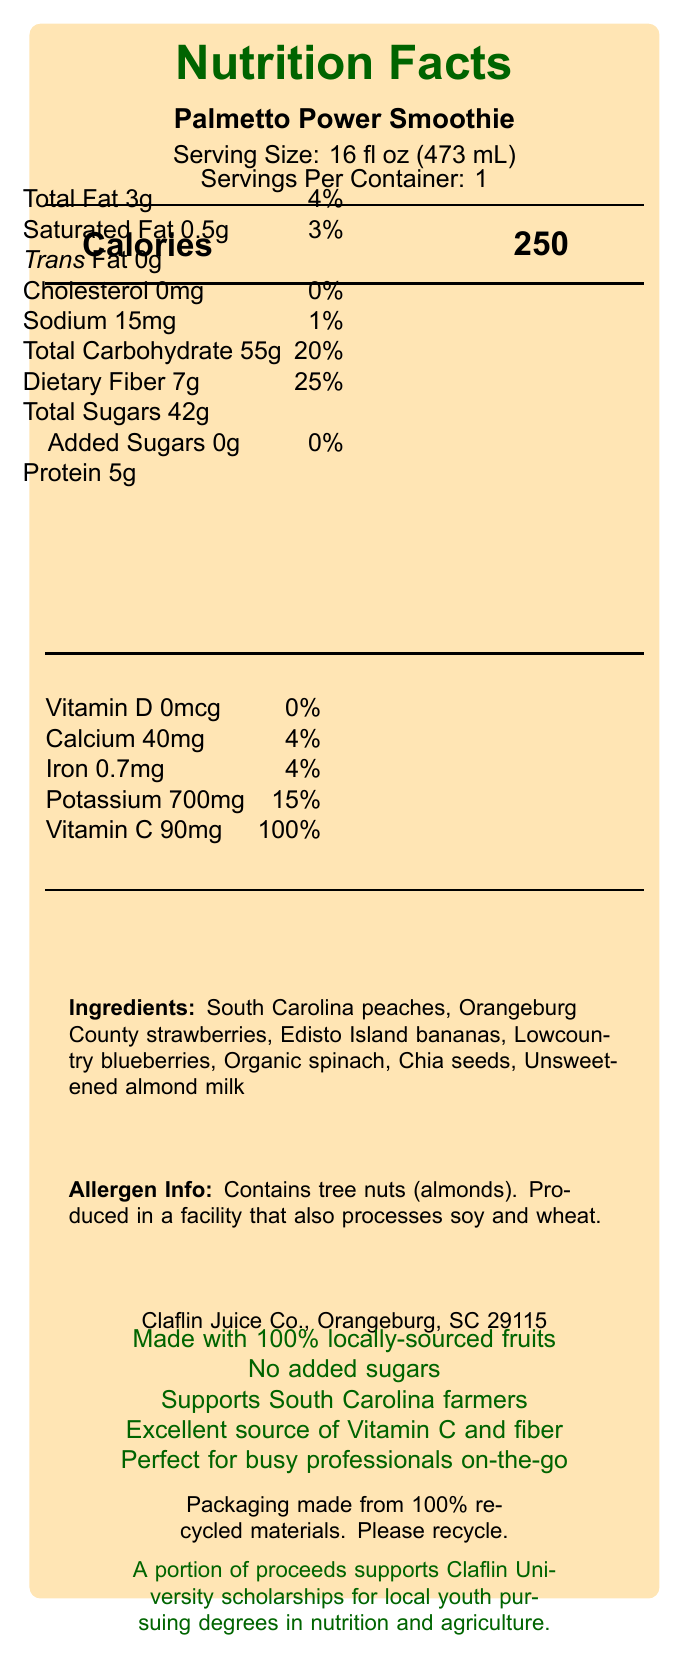what is the serving size of the Palmetto Power Smoothie? The document lists the serving size directly under the product name "Palmetto Power Smoothie" as "16 fl oz (473 mL)."
Answer: 16 fl oz (473 mL) how many calories does one serving of the Palmetto Power Smoothie contain? The document specifies the calories value next to the label "Calories".
Answer: 250 how much dietary fiber is in the Palmetto Power Smoothie? The document shows "Dietary Fiber 7g" under the nutrition facts.
Answer: 7g what ingredients are used in the Palmetto Power Smoothie? The document lists the ingredients under the "Ingredients" section.
Answer: South Carolina peaches, Orangeburg County strawberries, Edisto Island bananas, Lowcountry blueberries, Organic spinach, Chia seeds, Unsweetened almond milk does the Palmetto Power Smoothie contain any added sugars? Under the nutrition facts, the document states "Added Sugars 0g."
Answer: No does the Palmetto Power Smoothie contain any potentially allergenic ingredients? The allergen info mentions it contains tree nuts (almonds).
Answer: Yes who produces the Palmetto Power Smoothie? A. Orangeburg Juice Co., Orangeburg B. Claflin Juice Co., Orangeburg C. South Carolina Juice Co., Columbia D. Edisto Island Juice Co., Edisto Island The document states the producer as "Claflin Juice Co., Orangeburg, SC 29115."
Answer: B. Claflin Juice Co., Orangeburg what percentage of the daily value of Vitamin C does the Palmetto Power Smoothie provide? A. 50% B. 75% C. 100% D. 150% The document lists "Vitamin C 90mg" providing "100%".
Answer: C. 100% does the Palmetto Power Smoothie have any cholesterol? The document indicates "Cholesterol 0mg".
Answer: No does the product contain a sustainability statement? The document states "Packaging made from 100% recycled materials. Please recycle."
Answer: Yes can you summarize the main idea of the Palmetto Power Smoothie document? The document details the nutritional content and ingredients of the smoothie, along with promoting its local sourcing, health benefits, and community support.
Answer: The document provides the nutrition facts, ingredients, allergen information, and marketing claims for the Palmetto Power Smoothie. It highlights that the smoothie is made with locally sourced fruits, contains no added sugars, and supports local farmers and scholarships for youth. what is the total amount of potassium in the Palmetto Power Smoothie? The nutrition facts show "Potassium 700mg."
Answer: 700mg does this smoothie support any educational initiatives? The document mentions that a portion of proceeds supports scholarships for local youth.
Answer: Yes where are the bananas in the Palmetto Power Smoothie sourced from? The document lists "Edisto Island bananas" under ingredients.
Answer: Edisto Island is there any information about sugar content besides total sugars? The document specifies both "Total Sugars 42g" and "Added Sugars 0g."
Answer: Yes, it states that there are 0g of added sugars. how much protein does one serving of the Palmetto Power Smoothie contain? The document lists "Protein 5g."
Answer: 5g how many servings are there per container? The document specifies "Servings Per Container: 1."
Answer: 1 what marketing claims are made about the Palmetto Power Smoothie? The document lists the marketing claims under the section labeled for marketing claims.
Answer: Made with 100% locally-sourced fruits, No added sugars, Supports South Carolina farmers, Excellent source of Vitamin C and fiber, Perfect for busy professionals on-the-go what is the total fat content in one serving, and what percentage of the daily value does it provide? The nutrition facts state "Total Fat 3g" and "4%."
Answer: 3g, 4% what information is available about the vitamin D content in the smoothie? The nutrition facts display "Vitamin D 0mcg, 0%."
Answer: The smoothie contains 0mcg of Vitamin D, providing 0% of the daily value. what is the company's address? The document shows the company's address as "Claflin Juice Co., Orangeburg, SC 29115."
Answer: Orangeburg, SC 29115 does the Palmetto Power Smoothie have more fiber or sugars? The document states "Dietary Fiber 7g" and "Total Sugars 42g," so the smoothie has more sugars.
Answer: Sugars which fruit is not mentioned as an ingredient? A. Strawberries B. Blueberries C. Cherries D. Peaches The list of ingredients does not mention cherries, while it mentions strawberries, blueberries, and peaches.
Answer: C. Cherries how much iron does the Palmetto Power Smoothie provide? The document states the iron content as "Iron 0.7mg, 4%."
Answer: 0.7mg, 4% is there any information about the ethical or environmental impact of the product's packaging? The document mentions the packaging and recycling statement under sustainability.
Answer: Yes, the packaging is made from 100% recycled materials, and consumers are encouraged to recycle. what flavors are emphasized in the ingredients list? The ingredients list emphasizes flavors from "South Carolina peaches, Orangeburg County strawberries, Edisto Island bananas, Lowcountry blueberries."
Answer: Peach, strawberry, banana, blueberry what year was the Claflin Juice Co. established? The document does not provide information about the establishment year of Claflin Juice Co.
Answer: Cannot be determined 